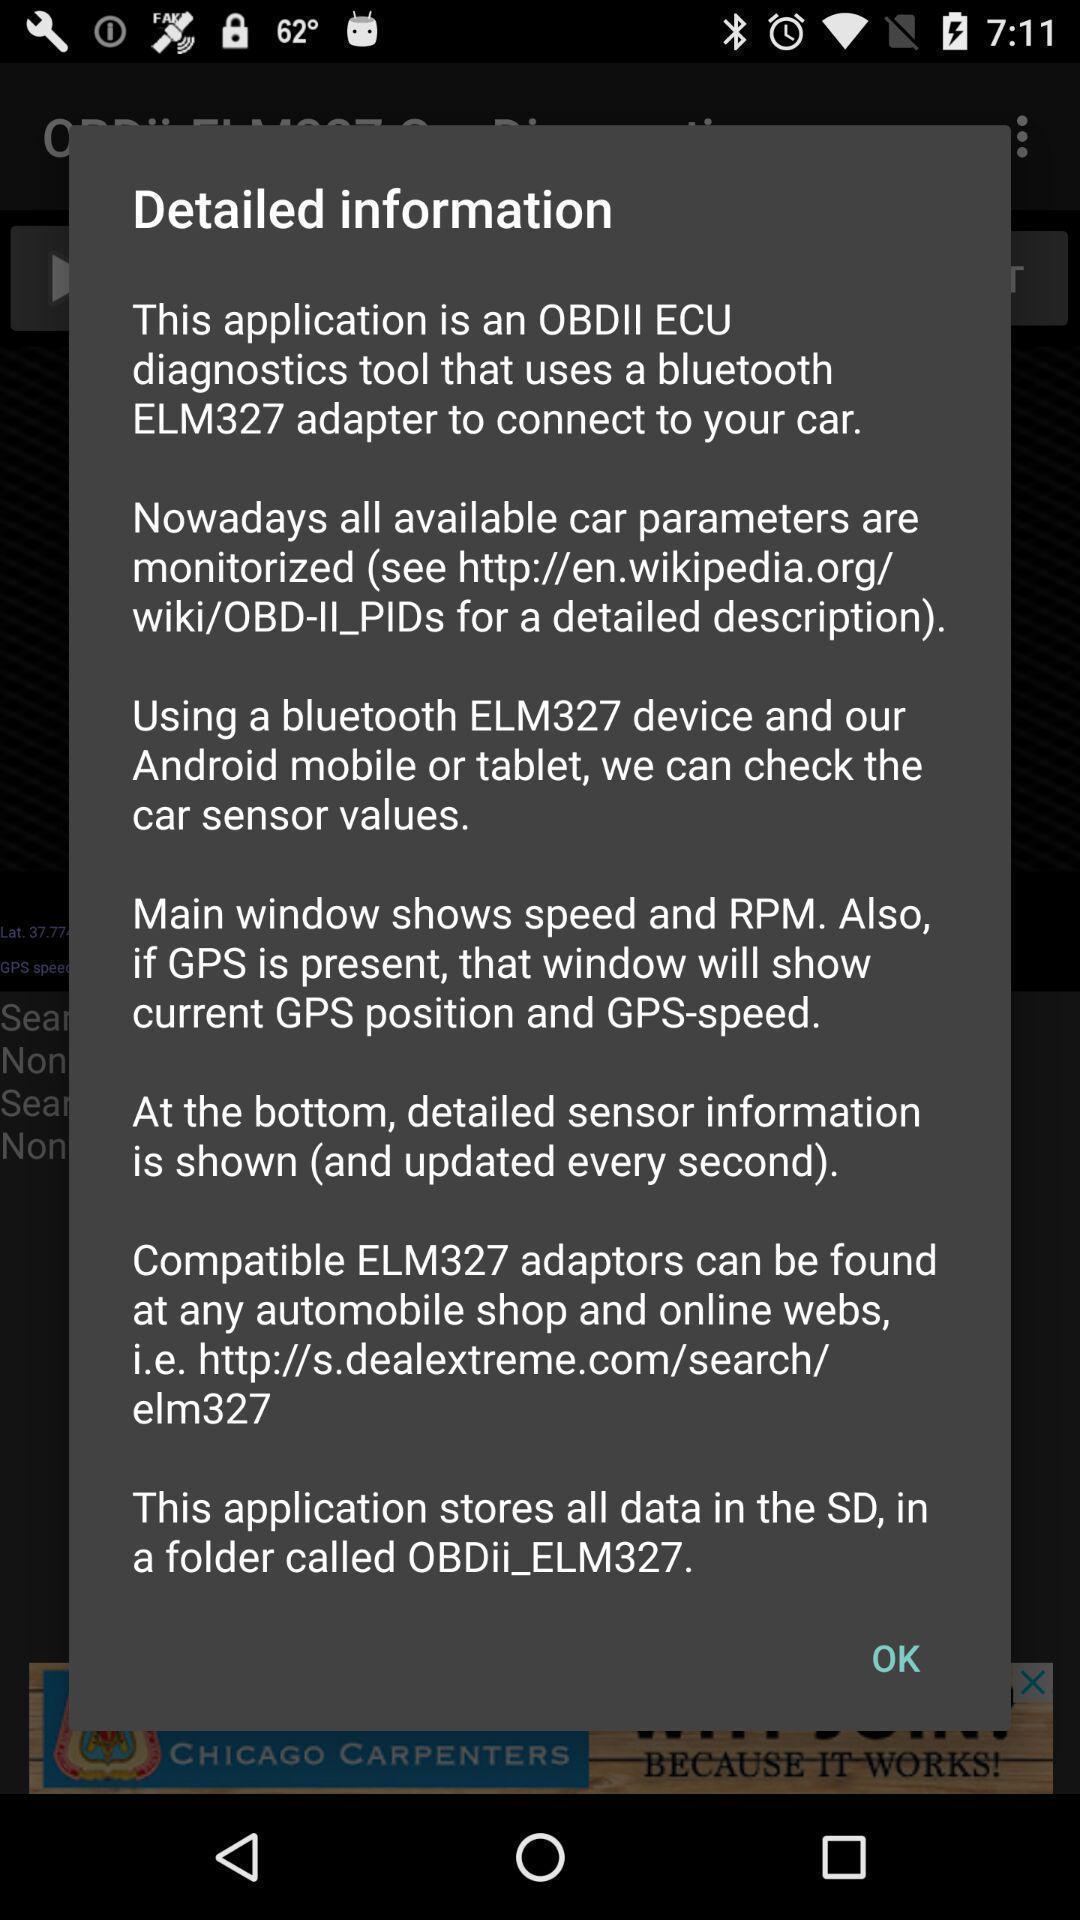Explain what's happening in this screen capture. Popup of detailed information about the vehicle app. 